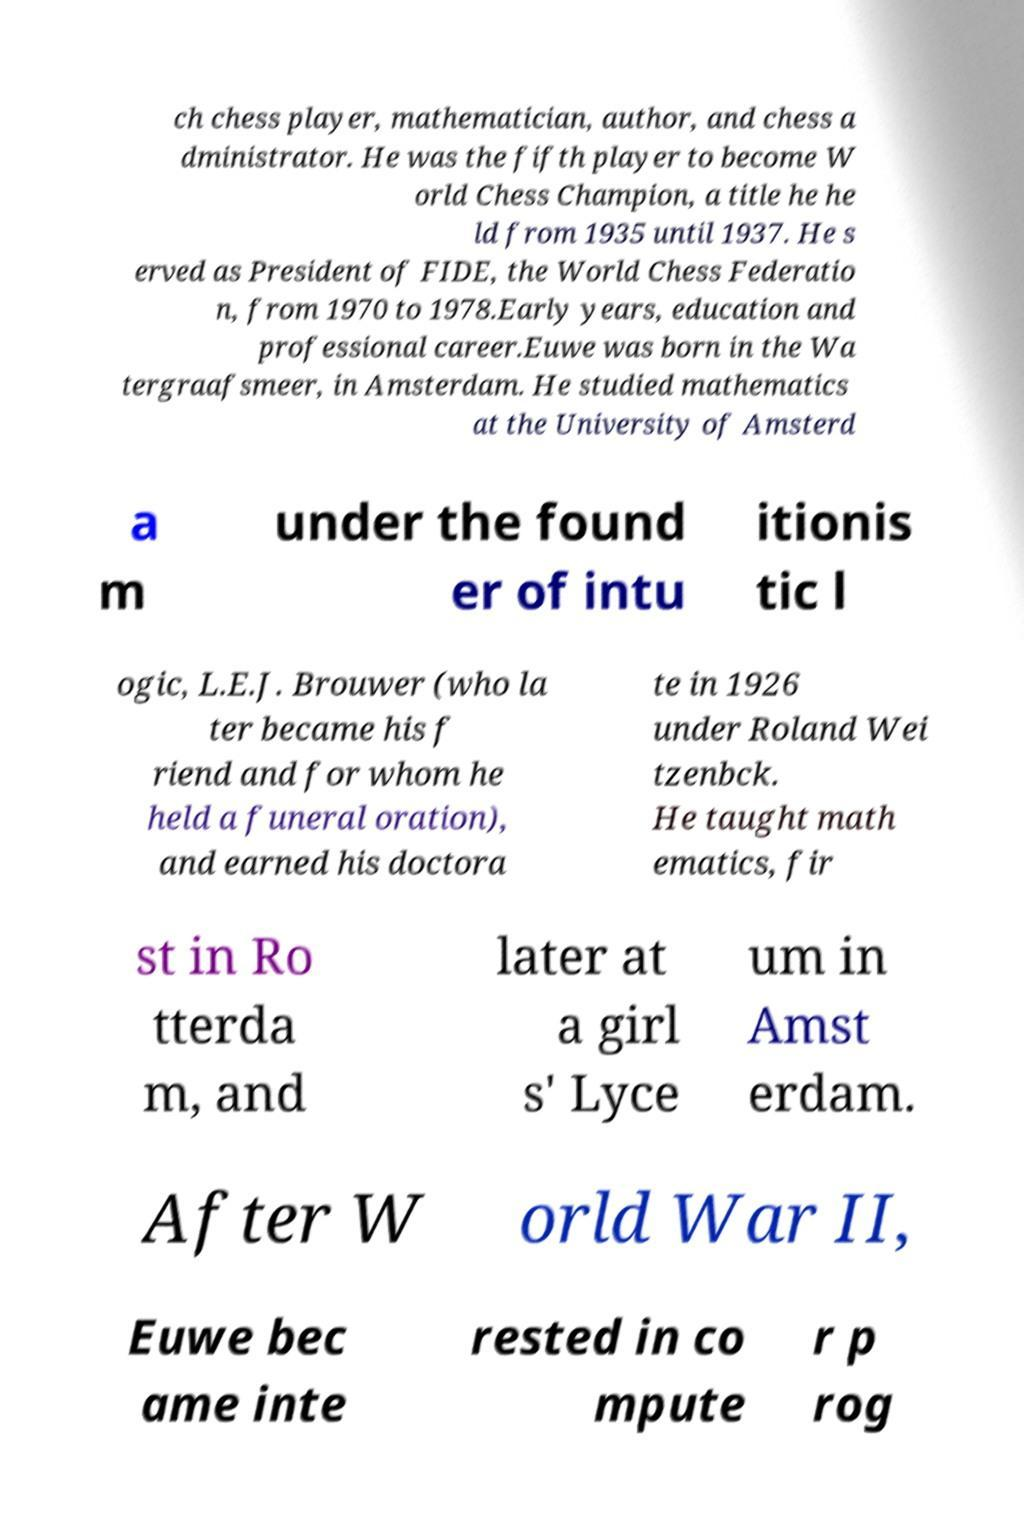There's text embedded in this image that I need extracted. Can you transcribe it verbatim? ch chess player, mathematician, author, and chess a dministrator. He was the fifth player to become W orld Chess Champion, a title he he ld from 1935 until 1937. He s erved as President of FIDE, the World Chess Federatio n, from 1970 to 1978.Early years, education and professional career.Euwe was born in the Wa tergraafsmeer, in Amsterdam. He studied mathematics at the University of Amsterd a m under the found er of intu itionis tic l ogic, L.E.J. Brouwer (who la ter became his f riend and for whom he held a funeral oration), and earned his doctora te in 1926 under Roland Wei tzenbck. He taught math ematics, fir st in Ro tterda m, and later at a girl s' Lyce um in Amst erdam. After W orld War II, Euwe bec ame inte rested in co mpute r p rog 